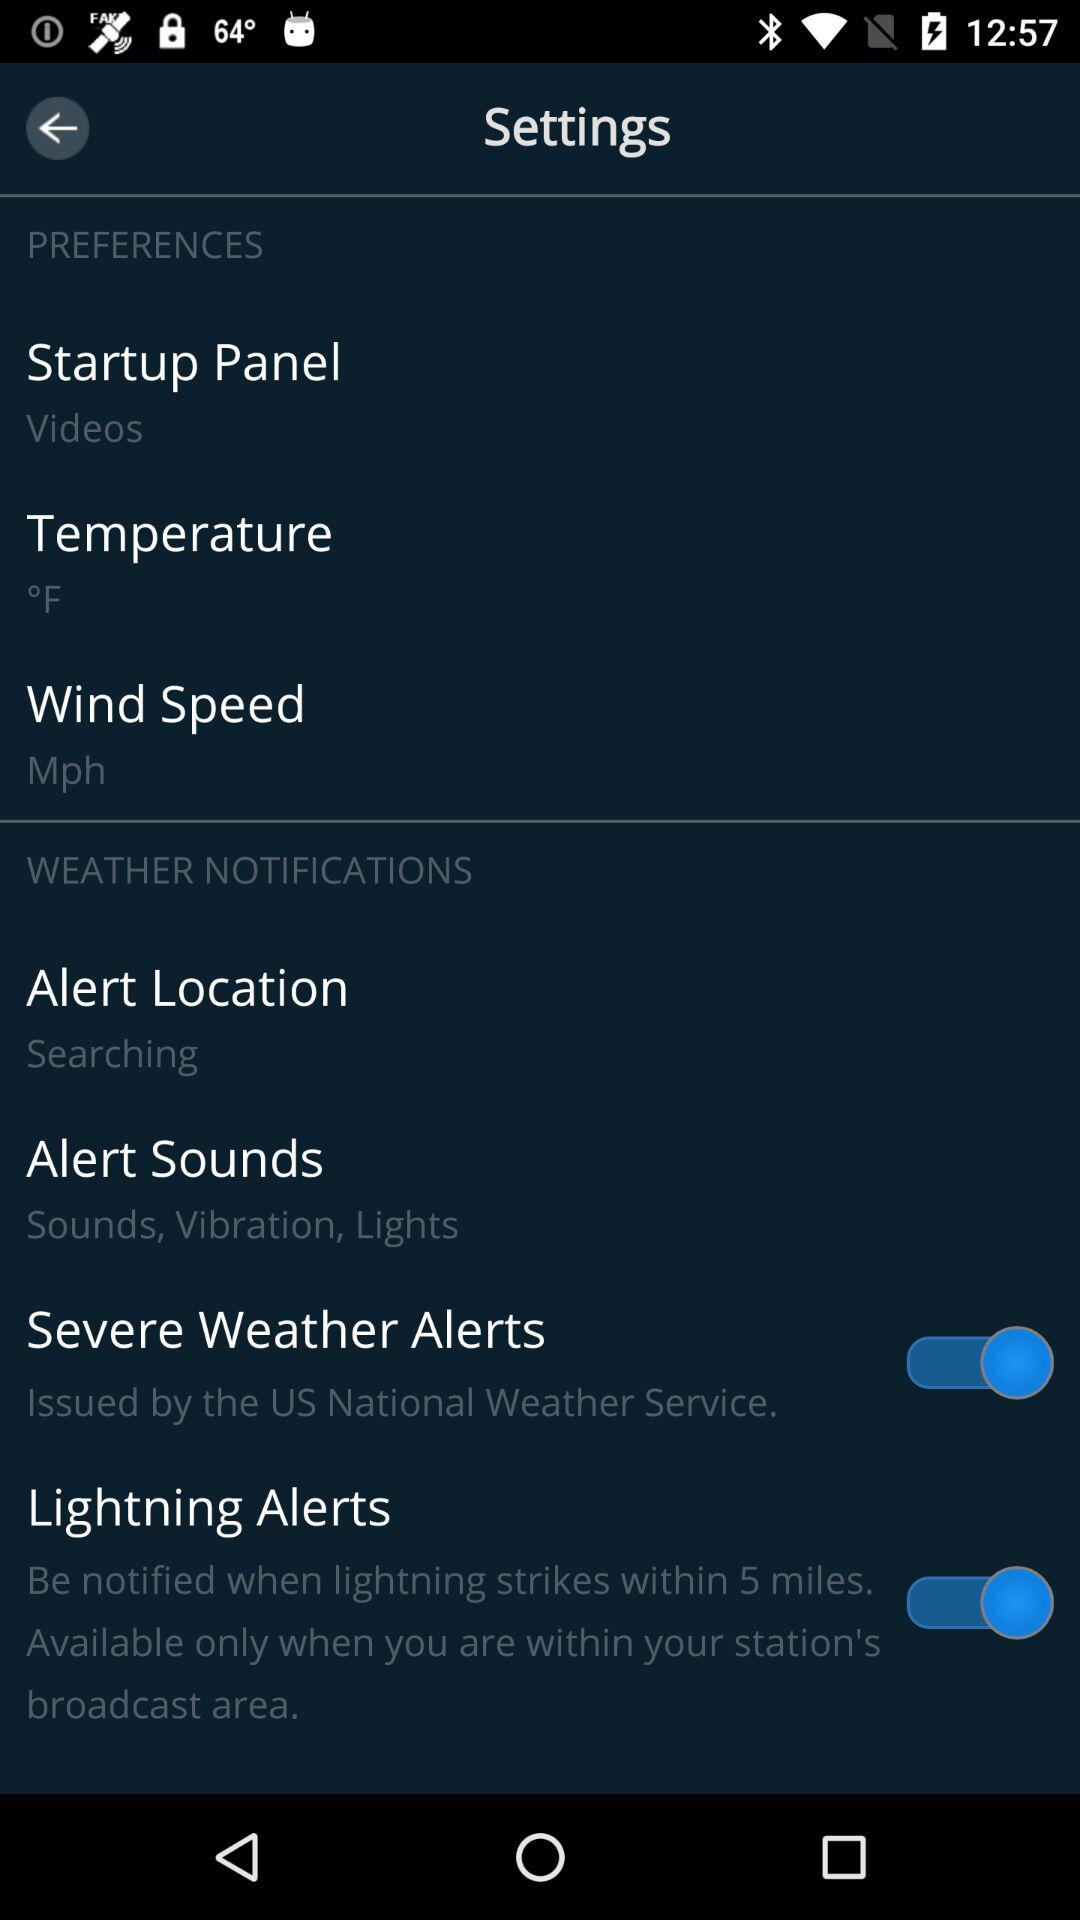What is the status of lightning alerts? The status is on. 